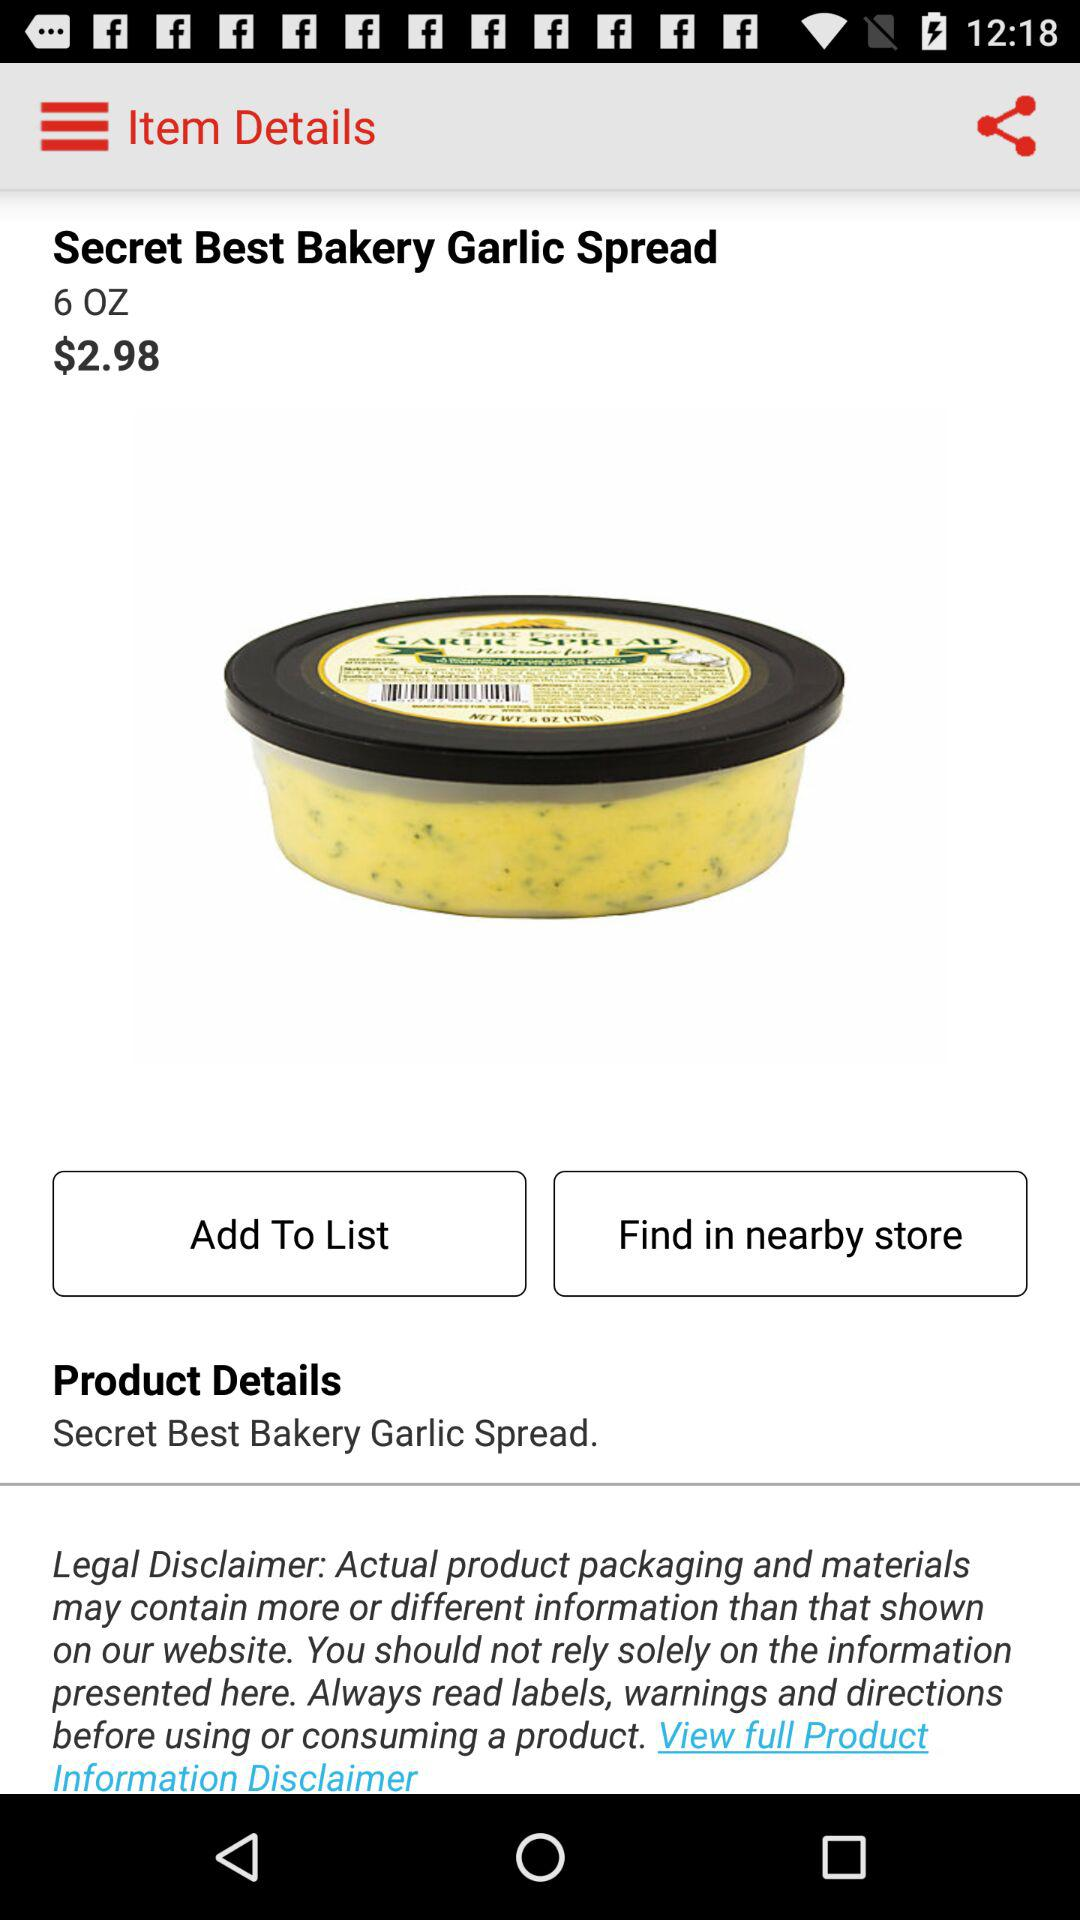How many ounces is the garlic spread?
Answer the question using a single word or phrase. 6 